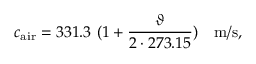Convert formula to latex. <formula><loc_0><loc_0><loc_500><loc_500>c _ { a i r } = 3 3 1 . 3 ( 1 + { \frac { \vartheta } { 2 \cdot 2 7 3 . 1 5 } } ) m / s ,</formula> 